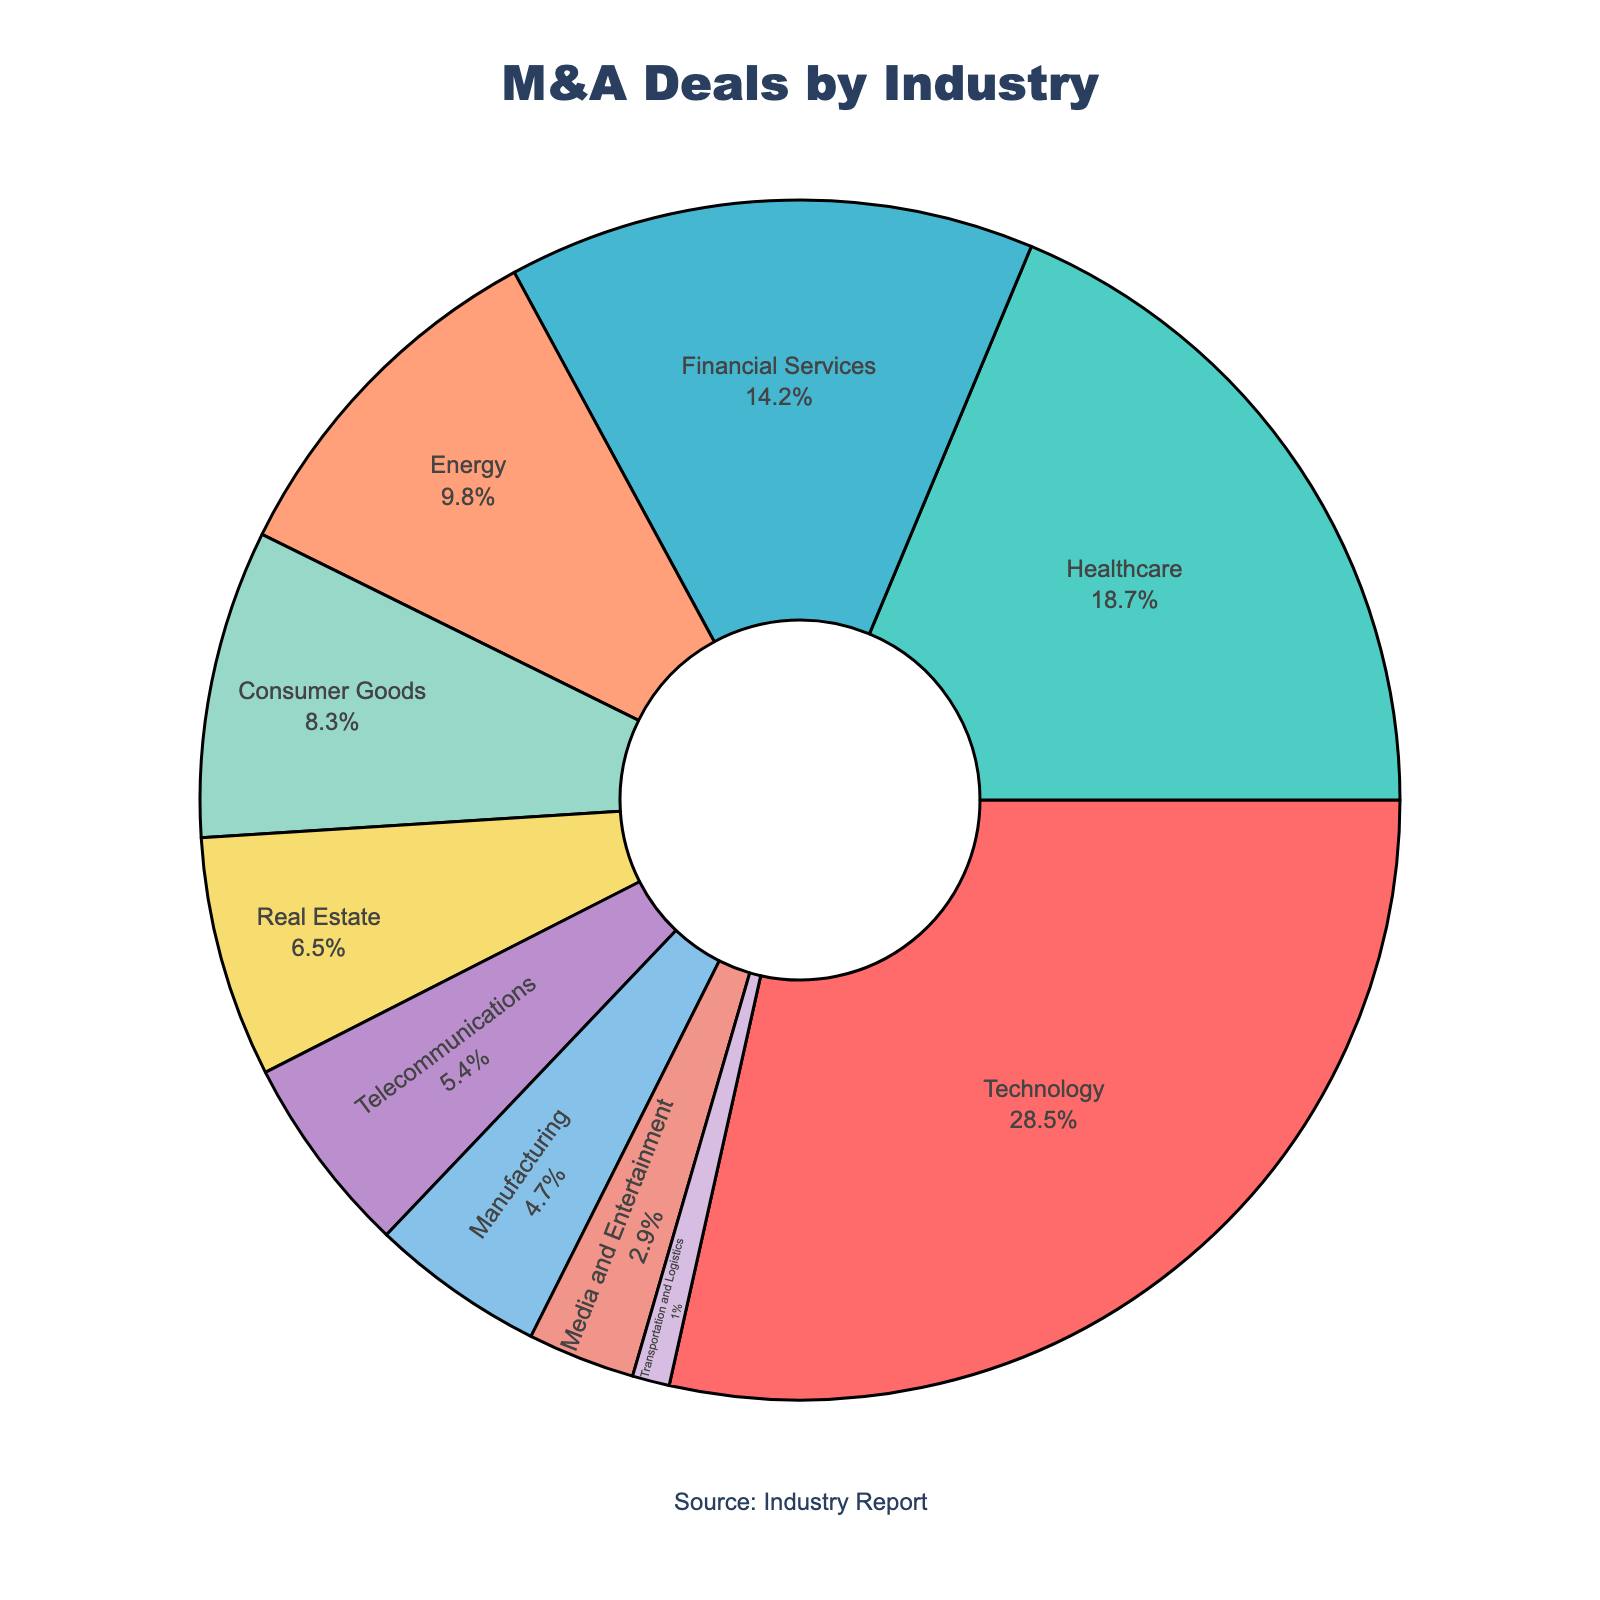What industry has the highest percentage of M&A deals? According to the pie chart, the Technology sector has the largest portion of the pie, indicating the highest percentage of M&A deals.
Answer: Technology Which industry has the lowest percentage of M&A deals? The smallest segment in the pie chart represents the Transportation and Logistics sector, indicating it has the lowest percentage of M&A deals.
Answer: Transportation and Logistics What is the combined percentage of M&A deals in the Healthcare and Financial Services industries? First, identify the percentages for Healthcare (18.7%) and Financial Services (14.2%) from the chart. Then add them together: 18.7% + 14.2% = 32.9%.
Answer: 32.9% Is the combined percentage of deals in Consumer Goods and Real Estate greater than the percentage in Technology? Add the percentages for Consumer Goods (8.3%) and Real Estate (6.5%), which gives 14.8%. Since Technology has a percentage of 28.5%, 14.8% < 28.5%.
Answer: No Which sector has a larger share of M&A deals, Energy or Telecommunications, and by how much? The pie chart shows Energy with 9.8% and Telecommunications with 5.4%. The difference is 9.8% - 5.4% = 4.4%.
Answer: Energy by 4.4% What is the median percentage value of the sectors displayed? First, list the percentages in ascending order: 1.0, 2.9, 4.7, 5.4, 6.5, 8.3, 9.8, 14.2, 18.7, 28.5. The median is the middle value of this ordered list, which is the average of the 5th and 6th values: (6.5 + 8.3)/2 = 7.4%.
Answer: 7.4% What percentage of deals involve industries other than Technology? Subtract the Technology percentage from 100%. That is, 100% - 28.5% = 71.5%.
Answer: 71.5% Which segments of the pie chart use shades of purple, and what are the corresponding industries? The pie chart uses shades of purple to represent Real Estate (6.5%) and Media and Entertainment (2.9%).
Answer: Real Estate and Media and Entertainment How much higher is the percentage of M&A deals in Healthcare than in Manufacturing? According to the chart, Healthcare is 18.7% and Manufacturing is 4.7%. The difference is 18.7% - 4.7% = 14%.
Answer: 14% What industry has approximately one-tenth the M&A deals percentage of Technology? The chart shows that Transportation and Logistics has 1% of M&A deals. Comparing with Technology's 28.5%, 1% is approximately one-tenth of 28.5%.
Answer: Transportation and Logistics 